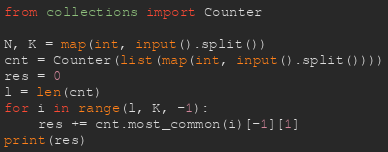Convert code to text. <code><loc_0><loc_0><loc_500><loc_500><_Python_>from collections import Counter

N, K = map(int, input().split())
cnt = Counter(list(map(int, input().split())))
res = 0
l = len(cnt)
for i in range(l, K, -1):
    res += cnt.most_common(i)[-1][1]
print(res)</code> 